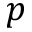Convert formula to latex. <formula><loc_0><loc_0><loc_500><loc_500>p</formula> 